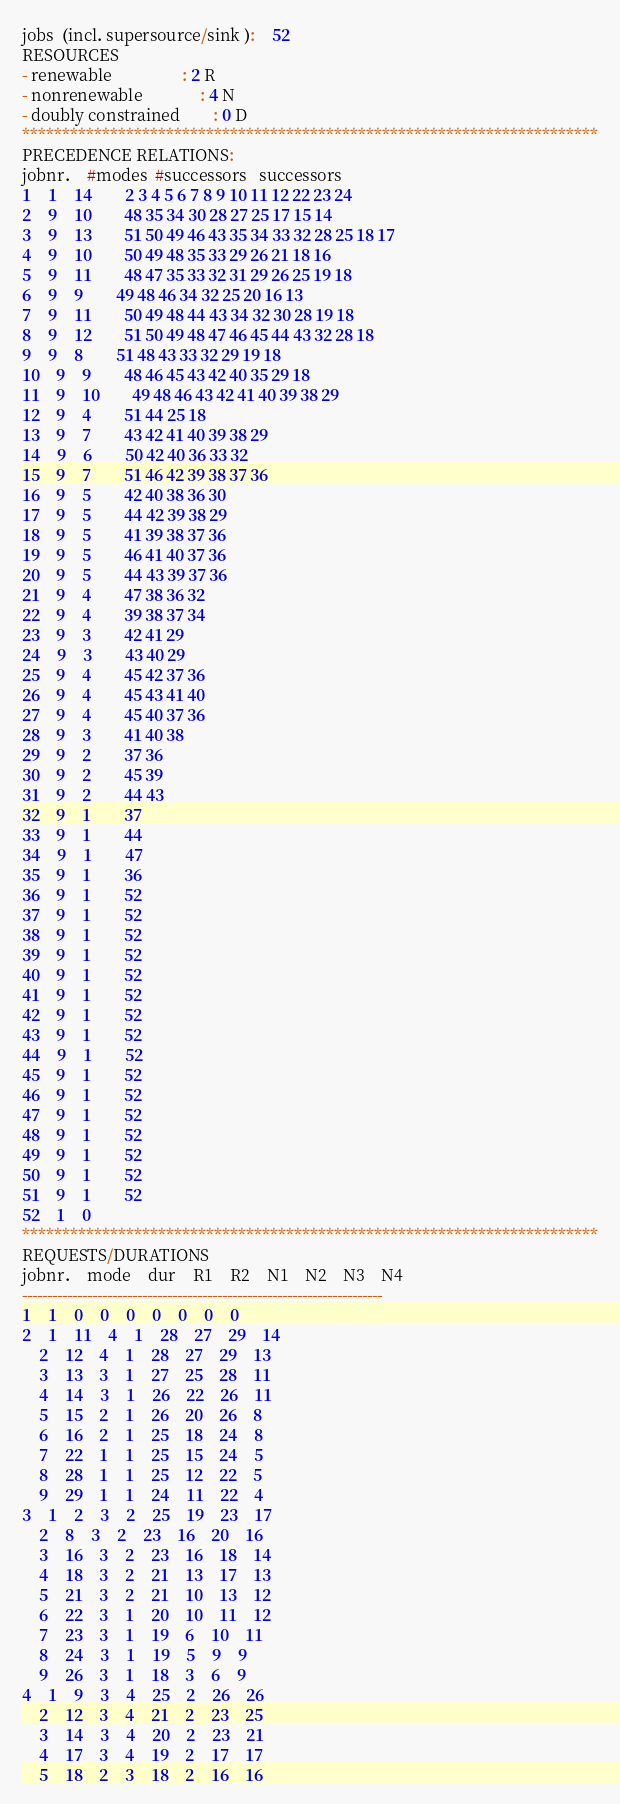Convert code to text. <code><loc_0><loc_0><loc_500><loc_500><_ObjectiveC_>jobs  (incl. supersource/sink ):	52
RESOURCES
- renewable                 : 2 R
- nonrenewable              : 4 N
- doubly constrained        : 0 D
************************************************************************
PRECEDENCE RELATIONS:
jobnr.    #modes  #successors   successors
1	1	14		2 3 4 5 6 7 8 9 10 11 12 22 23 24 
2	9	10		48 35 34 30 28 27 25 17 15 14 
3	9	13		51 50 49 46 43 35 34 33 32 28 25 18 17 
4	9	10		50 49 48 35 33 29 26 21 18 16 
5	9	11		48 47 35 33 32 31 29 26 25 19 18 
6	9	9		49 48 46 34 32 25 20 16 13 
7	9	11		50 49 48 44 43 34 32 30 28 19 18 
8	9	12		51 50 49 48 47 46 45 44 43 32 28 18 
9	9	8		51 48 43 33 32 29 19 18 
10	9	9		48 46 45 43 42 40 35 29 18 
11	9	10		49 48 46 43 42 41 40 39 38 29 
12	9	4		51 44 25 18 
13	9	7		43 42 41 40 39 38 29 
14	9	6		50 42 40 36 33 32 
15	9	7		51 46 42 39 38 37 36 
16	9	5		42 40 38 36 30 
17	9	5		44 42 39 38 29 
18	9	5		41 39 38 37 36 
19	9	5		46 41 40 37 36 
20	9	5		44 43 39 37 36 
21	9	4		47 38 36 32 
22	9	4		39 38 37 34 
23	9	3		42 41 29 
24	9	3		43 40 29 
25	9	4		45 42 37 36 
26	9	4		45 43 41 40 
27	9	4		45 40 37 36 
28	9	3		41 40 38 
29	9	2		37 36 
30	9	2		45 39 
31	9	2		44 43 
32	9	1		37 
33	9	1		44 
34	9	1		47 
35	9	1		36 
36	9	1		52 
37	9	1		52 
38	9	1		52 
39	9	1		52 
40	9	1		52 
41	9	1		52 
42	9	1		52 
43	9	1		52 
44	9	1		52 
45	9	1		52 
46	9	1		52 
47	9	1		52 
48	9	1		52 
49	9	1		52 
50	9	1		52 
51	9	1		52 
52	1	0		
************************************************************************
REQUESTS/DURATIONS
jobnr.	mode	dur	R1	R2	N1	N2	N3	N4	
------------------------------------------------------------------------
1	1	0	0	0	0	0	0	0	
2	1	11	4	1	28	27	29	14	
	2	12	4	1	28	27	29	13	
	3	13	3	1	27	25	28	11	
	4	14	3	1	26	22	26	11	
	5	15	2	1	26	20	26	8	
	6	16	2	1	25	18	24	8	
	7	22	1	1	25	15	24	5	
	8	28	1	1	25	12	22	5	
	9	29	1	1	24	11	22	4	
3	1	2	3	2	25	19	23	17	
	2	8	3	2	23	16	20	16	
	3	16	3	2	23	16	18	14	
	4	18	3	2	21	13	17	13	
	5	21	3	2	21	10	13	12	
	6	22	3	1	20	10	11	12	
	7	23	3	1	19	6	10	11	
	8	24	3	1	19	5	9	9	
	9	26	3	1	18	3	6	9	
4	1	9	3	4	25	2	26	26	
	2	12	3	4	21	2	23	25	
	3	14	3	4	20	2	23	21	
	4	17	3	4	19	2	17	17	
	5	18	2	3	18	2	16	16	</code> 